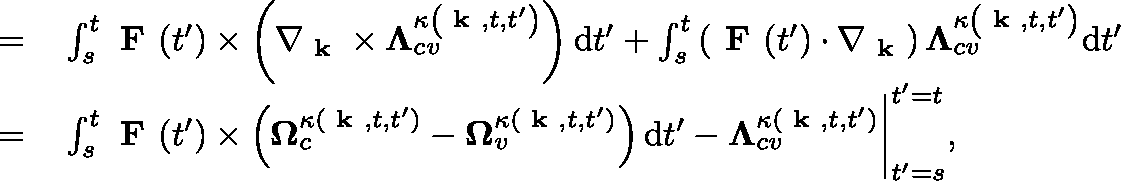<formula> <loc_0><loc_0><loc_500><loc_500>\begin{array} { r l } { = } & \int _ { s } ^ { t } F ( t ^ { \prime } ) \times \left ( \nabla _ { k } \times \Lambda _ { c v } ^ { \kappa \left ( k , t , t ^ { \prime } \right ) } \right ) d t ^ { \prime } + \int _ { s } ^ { t } \left ( F ( t ^ { \prime } ) \cdot \nabla _ { k } \right ) \Lambda _ { c v } ^ { \kappa \left ( k , t , t ^ { \prime } \right ) } d t ^ { \prime } } \\ { = } & \int _ { s } ^ { t } F ( t ^ { \prime } ) \times \left ( \Omega _ { c } ^ { \kappa ( k , t , t ^ { \prime } ) } - \Omega _ { v } ^ { \kappa ( k , t , t ^ { \prime } ) } \right ) d t ^ { \prime } - \Lambda _ { c v } ^ { \kappa ( k , t , t ^ { \prime } ) } \Big | _ { t ^ { \prime } = s } ^ { t ^ { \prime } = t } , } \end{array}</formula> 